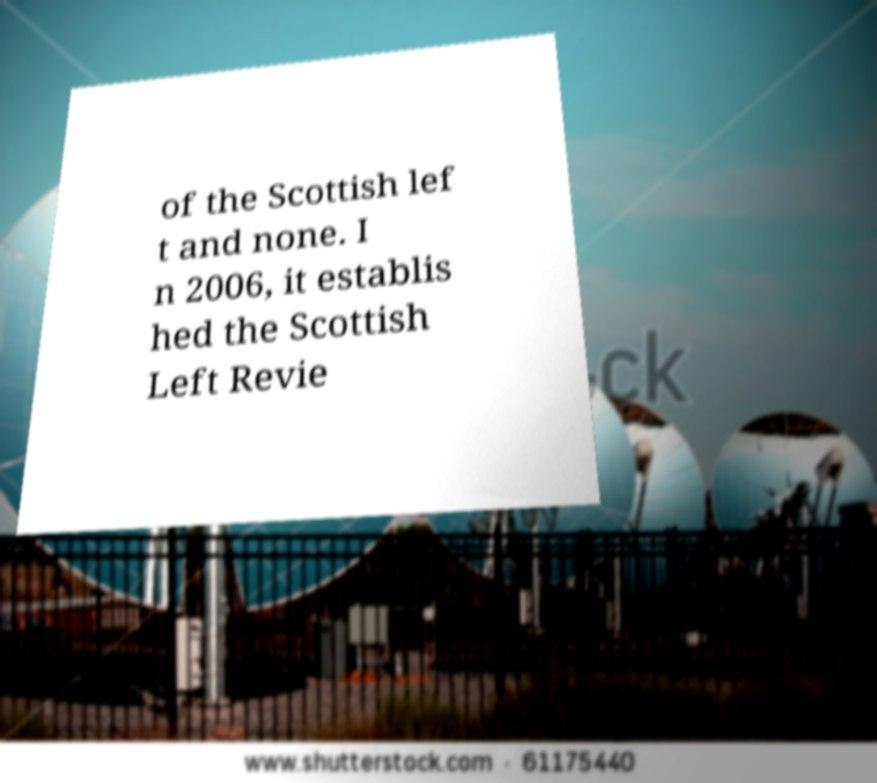Can you accurately transcribe the text from the provided image for me? of the Scottish lef t and none. I n 2006, it establis hed the Scottish Left Revie 